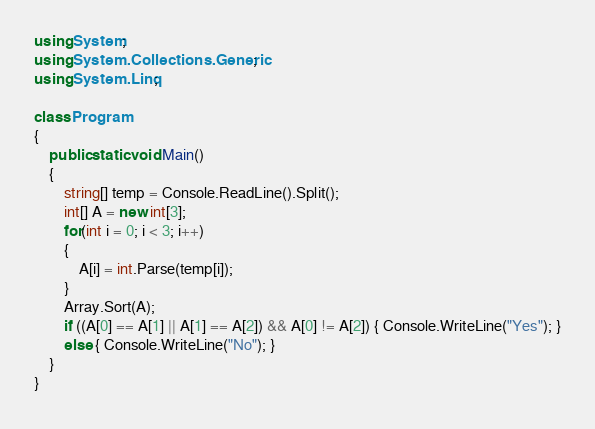<code> <loc_0><loc_0><loc_500><loc_500><_C#_>using System;
using System.Collections.Generic;
using System.Linq;

class Program
{
    public static void Main()
    {
        string[] temp = Console.ReadLine().Split();
        int[] A = new int[3];
        for(int i = 0; i < 3; i++)
        {
            A[i] = int.Parse(temp[i]);
        }
        Array.Sort(A);
        if ((A[0] == A[1] || A[1] == A[2]) && A[0] != A[2]) { Console.WriteLine("Yes"); }
        else { Console.WriteLine("No"); }
    }
}</code> 